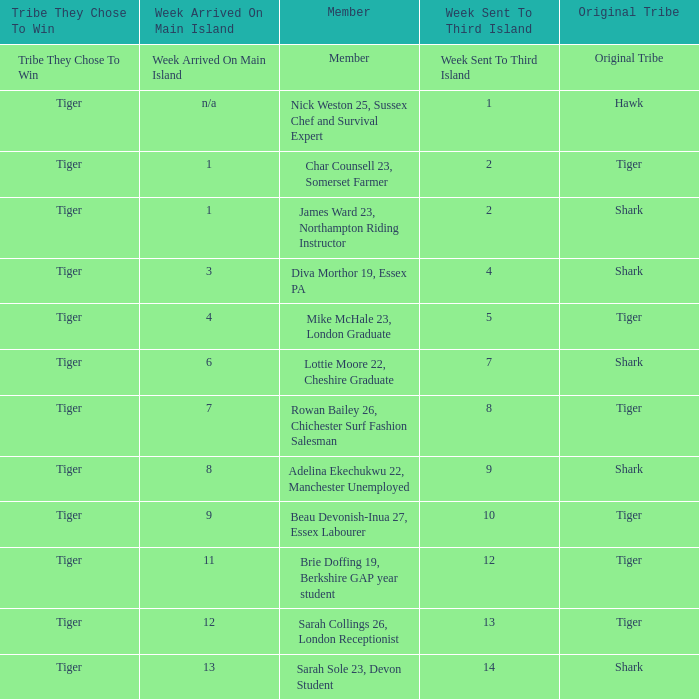What week did the member who's original tribe was shark and who was sent to the third island on week 14 arrive on the main island? 13.0. 